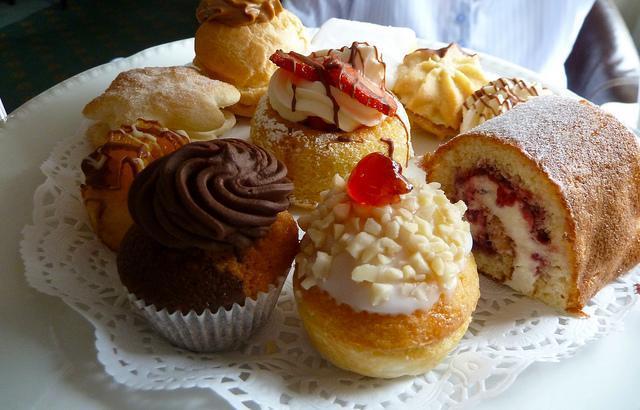How many desserts are on the doily?
Give a very brief answer. 9. How many cakes are there?
Give a very brief answer. 9. How many sandwiches are there?
Give a very brief answer. 0. 